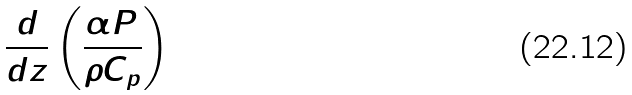Convert formula to latex. <formula><loc_0><loc_0><loc_500><loc_500>\frac { d } { d z } \left ( \frac { \alpha P } { \rho C _ { p } } \right )</formula> 